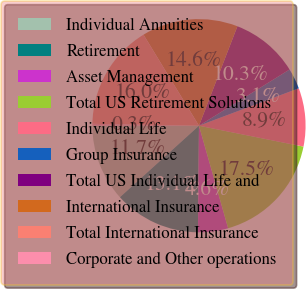Convert chart to OTSL. <chart><loc_0><loc_0><loc_500><loc_500><pie_chart><fcel>Individual Annuities<fcel>Retirement<fcel>Asset Management<fcel>Total US Retirement Solutions<fcel>Individual Life<fcel>Group Insurance<fcel>Total US Individual Life and<fcel>International Insurance<fcel>Total International Insurance<fcel>Corporate and Other operations<nl><fcel>11.72%<fcel>13.15%<fcel>4.56%<fcel>17.45%<fcel>8.85%<fcel>3.13%<fcel>10.29%<fcel>14.58%<fcel>16.01%<fcel>0.26%<nl></chart> 